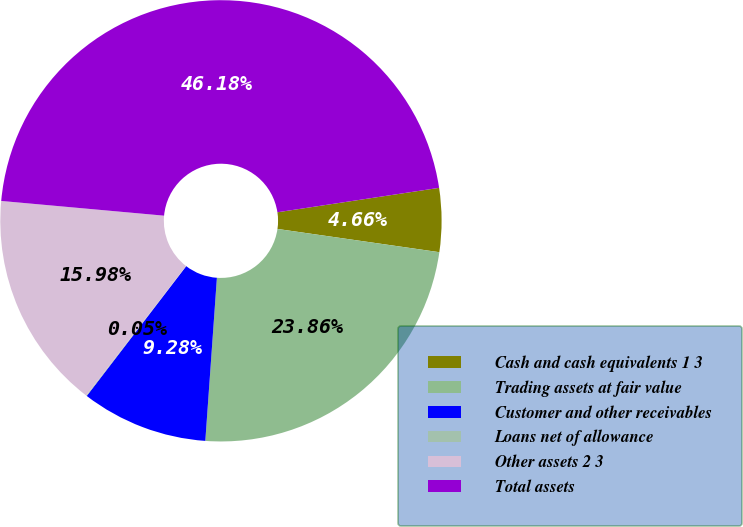Convert chart. <chart><loc_0><loc_0><loc_500><loc_500><pie_chart><fcel>Cash and cash equivalents 1 3<fcel>Trading assets at fair value<fcel>Customer and other receivables<fcel>Loans net of allowance<fcel>Other assets 2 3<fcel>Total assets<nl><fcel>4.66%<fcel>23.86%<fcel>9.28%<fcel>0.05%<fcel>15.98%<fcel>46.18%<nl></chart> 